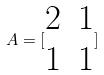Convert formula to latex. <formula><loc_0><loc_0><loc_500><loc_500>A = [ \begin{matrix} 2 & 1 \\ 1 & 1 \end{matrix} ]</formula> 